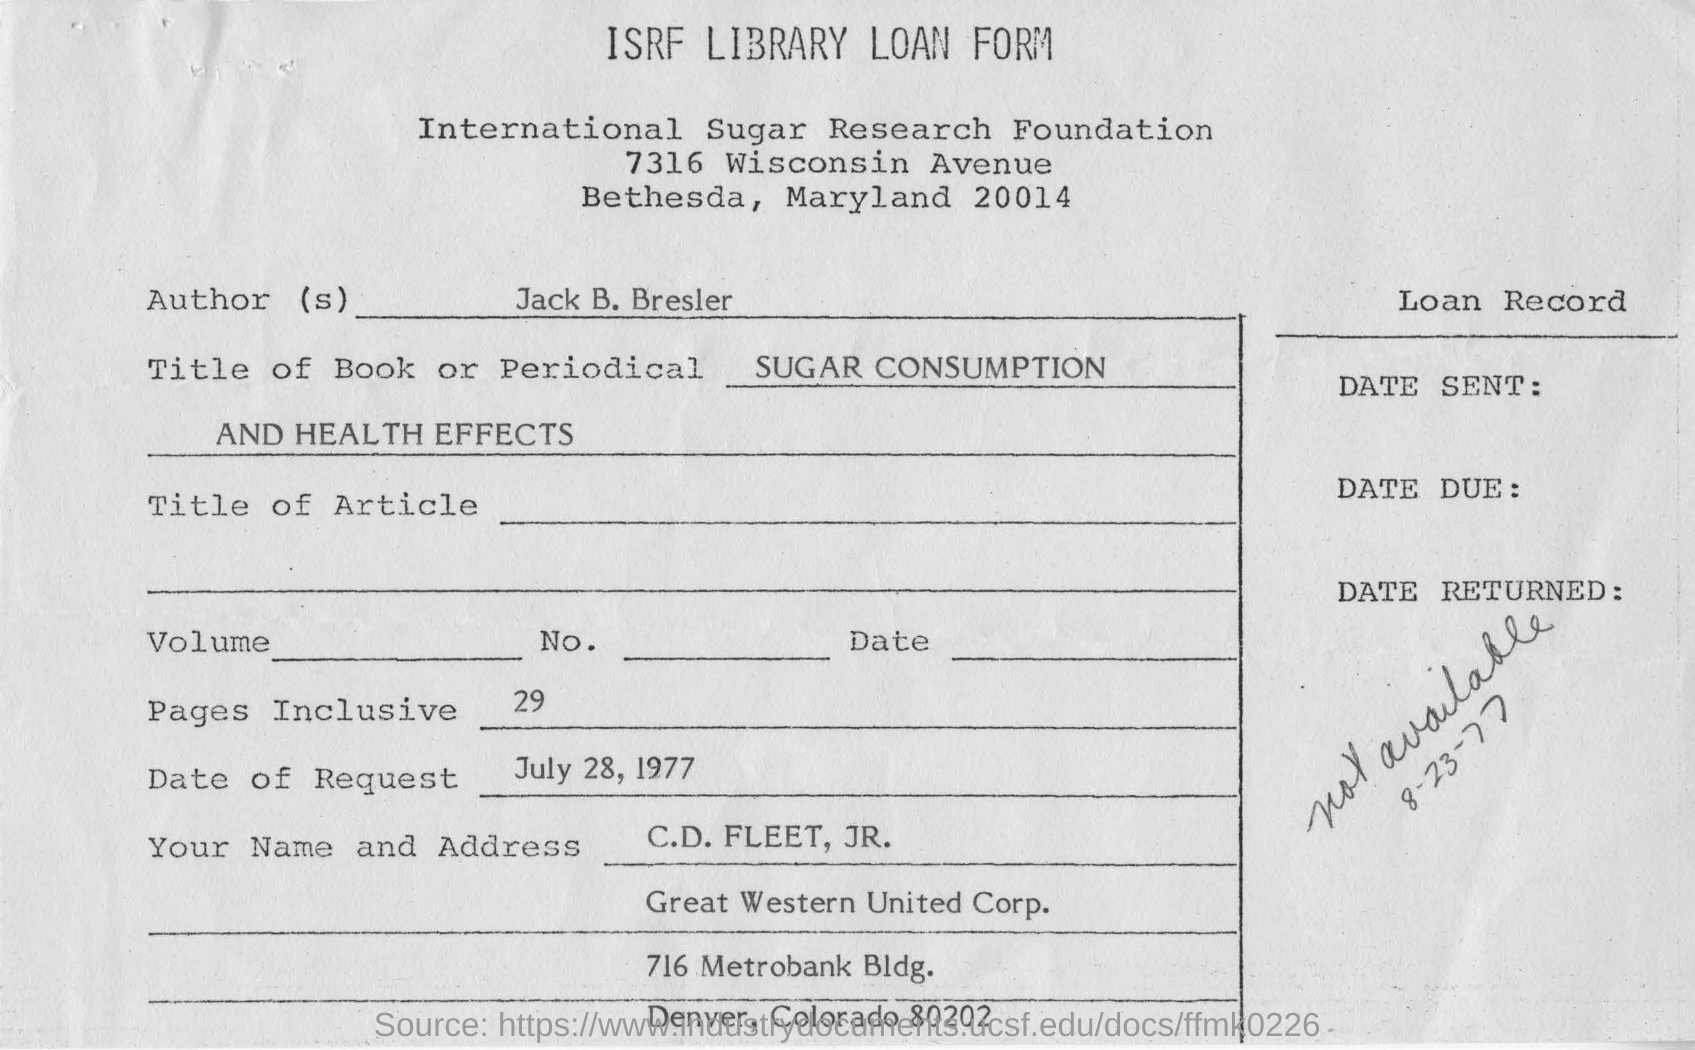What kind of form is this?
Provide a succinct answer. ISRF LIBRARY LOAN FORM. What is the fullform of ISRF?
Your answer should be compact. International Sugar Research Foundation. What is the author's name mentioned in this form?
Keep it short and to the point. Jack B. Bresler. What is the date of request given in the form?
Your answer should be compact. July 28, 1977. What are the no of pages inclusive?
Offer a very short reply. 29. What is the title of the book or periodical?
Provide a short and direct response. SUGAR CONSUMPTION AND HEALTH EFFECTS. What is the applicant's name given in the form?
Provide a succinct answer. C.D.FLEET, JR. 